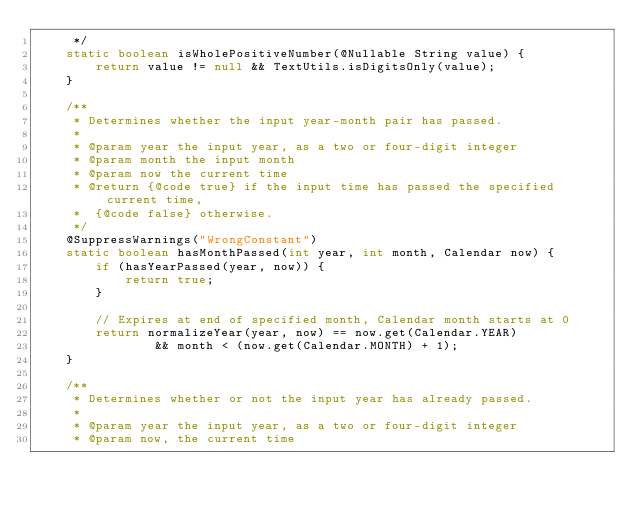Convert code to text. <code><loc_0><loc_0><loc_500><loc_500><_Java_>     */
    static boolean isWholePositiveNumber(@Nullable String value) {
        return value != null && TextUtils.isDigitsOnly(value);
    }

    /**
     * Determines whether the input year-month pair has passed.
     *
     * @param year the input year, as a two or four-digit integer
     * @param month the input month
     * @param now the current time
     * @return {@code true} if the input time has passed the specified current time,
     *  {@code false} otherwise.
     */
    @SuppressWarnings("WrongConstant")
    static boolean hasMonthPassed(int year, int month, Calendar now) {
        if (hasYearPassed(year, now)) {
            return true;
        }

        // Expires at end of specified month, Calendar month starts at 0
        return normalizeYear(year, now) == now.get(Calendar.YEAR)
                && month < (now.get(Calendar.MONTH) + 1);
    }

    /**
     * Determines whether or not the input year has already passed.
     *
     * @param year the input year, as a two or four-digit integer
     * @param now, the current time</code> 